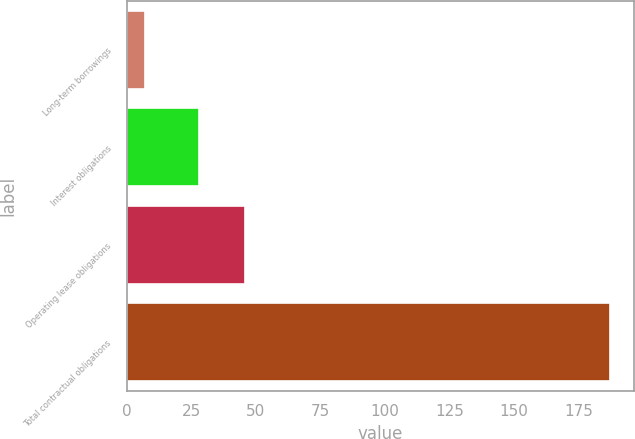Convert chart. <chart><loc_0><loc_0><loc_500><loc_500><bar_chart><fcel>Long-term borrowings<fcel>Interest obligations<fcel>Operating lease obligations<fcel>Total contractual obligations<nl><fcel>7<fcel>28<fcel>46<fcel>187<nl></chart> 